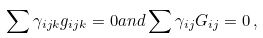<formula> <loc_0><loc_0><loc_500><loc_500>\sum \gamma _ { i j k } g _ { i j k } = 0 a n d \sum \gamma _ { i j } G _ { i j } = 0 \, ,</formula> 